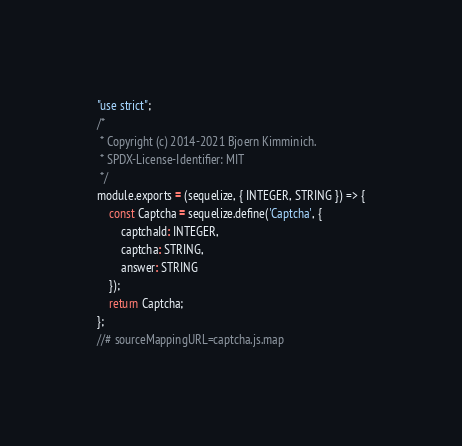<code> <loc_0><loc_0><loc_500><loc_500><_JavaScript_>"use strict";
/*
 * Copyright (c) 2014-2021 Bjoern Kimminich.
 * SPDX-License-Identifier: MIT
 */
module.exports = (sequelize, { INTEGER, STRING }) => {
    const Captcha = sequelize.define('Captcha', {
        captchaId: INTEGER,
        captcha: STRING,
        answer: STRING
    });
    return Captcha;
};
//# sourceMappingURL=captcha.js.map</code> 